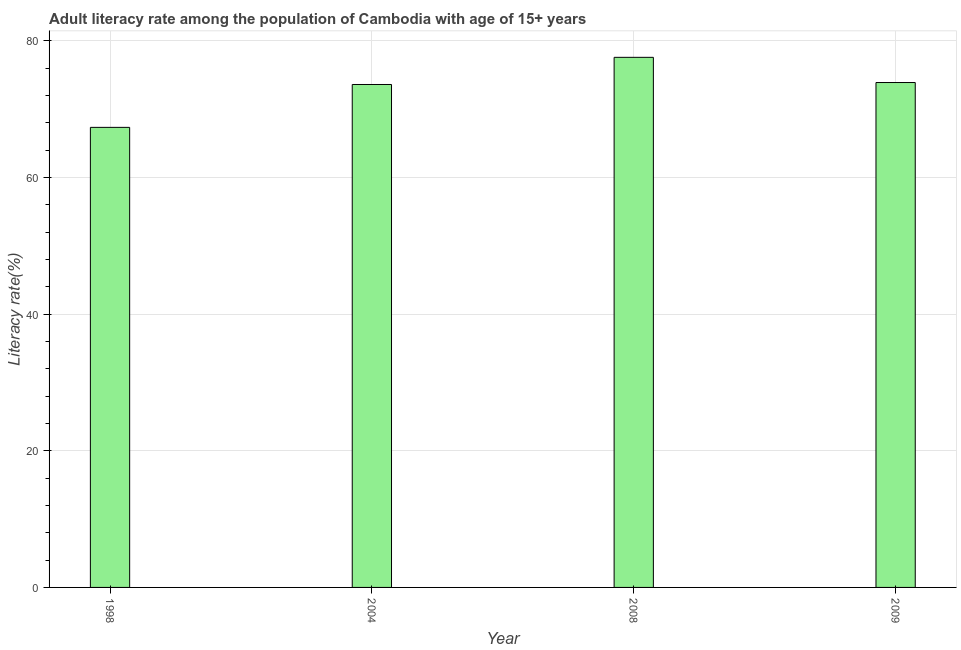What is the title of the graph?
Make the answer very short. Adult literacy rate among the population of Cambodia with age of 15+ years. What is the label or title of the X-axis?
Your answer should be compact. Year. What is the label or title of the Y-axis?
Ensure brevity in your answer.  Literacy rate(%). What is the adult literacy rate in 1998?
Your response must be concise. 67.34. Across all years, what is the maximum adult literacy rate?
Offer a very short reply. 77.59. Across all years, what is the minimum adult literacy rate?
Keep it short and to the point. 67.34. In which year was the adult literacy rate minimum?
Offer a very short reply. 1998. What is the sum of the adult literacy rate?
Give a very brief answer. 292.43. What is the difference between the adult literacy rate in 2008 and 2009?
Keep it short and to the point. 3.69. What is the average adult literacy rate per year?
Give a very brief answer. 73.11. What is the median adult literacy rate?
Your response must be concise. 73.75. In how many years, is the adult literacy rate greater than 60 %?
Provide a succinct answer. 4. Do a majority of the years between 1998 and 2004 (inclusive) have adult literacy rate greater than 60 %?
Ensure brevity in your answer.  Yes. What is the ratio of the adult literacy rate in 1998 to that in 2008?
Provide a short and direct response. 0.87. Is the difference between the adult literacy rate in 2008 and 2009 greater than the difference between any two years?
Your response must be concise. No. What is the difference between the highest and the second highest adult literacy rate?
Offer a terse response. 3.69. Is the sum of the adult literacy rate in 1998 and 2008 greater than the maximum adult literacy rate across all years?
Offer a very short reply. Yes. What is the difference between the highest and the lowest adult literacy rate?
Provide a short and direct response. 10.25. In how many years, is the adult literacy rate greater than the average adult literacy rate taken over all years?
Ensure brevity in your answer.  3. Are all the bars in the graph horizontal?
Keep it short and to the point. No. How many years are there in the graph?
Your answer should be compact. 4. What is the Literacy rate(%) of 1998?
Offer a very short reply. 67.34. What is the Literacy rate(%) in 2004?
Give a very brief answer. 73.61. What is the Literacy rate(%) in 2008?
Make the answer very short. 77.59. What is the Literacy rate(%) in 2009?
Provide a succinct answer. 73.9. What is the difference between the Literacy rate(%) in 1998 and 2004?
Your answer should be compact. -6.27. What is the difference between the Literacy rate(%) in 1998 and 2008?
Offer a very short reply. -10.25. What is the difference between the Literacy rate(%) in 1998 and 2009?
Provide a short and direct response. -6.56. What is the difference between the Literacy rate(%) in 2004 and 2008?
Provide a succinct answer. -3.98. What is the difference between the Literacy rate(%) in 2004 and 2009?
Provide a short and direct response. -0.29. What is the difference between the Literacy rate(%) in 2008 and 2009?
Your answer should be compact. 3.69. What is the ratio of the Literacy rate(%) in 1998 to that in 2004?
Your answer should be very brief. 0.92. What is the ratio of the Literacy rate(%) in 1998 to that in 2008?
Keep it short and to the point. 0.87. What is the ratio of the Literacy rate(%) in 1998 to that in 2009?
Give a very brief answer. 0.91. What is the ratio of the Literacy rate(%) in 2004 to that in 2008?
Your response must be concise. 0.95. What is the ratio of the Literacy rate(%) in 2008 to that in 2009?
Your answer should be very brief. 1.05. 